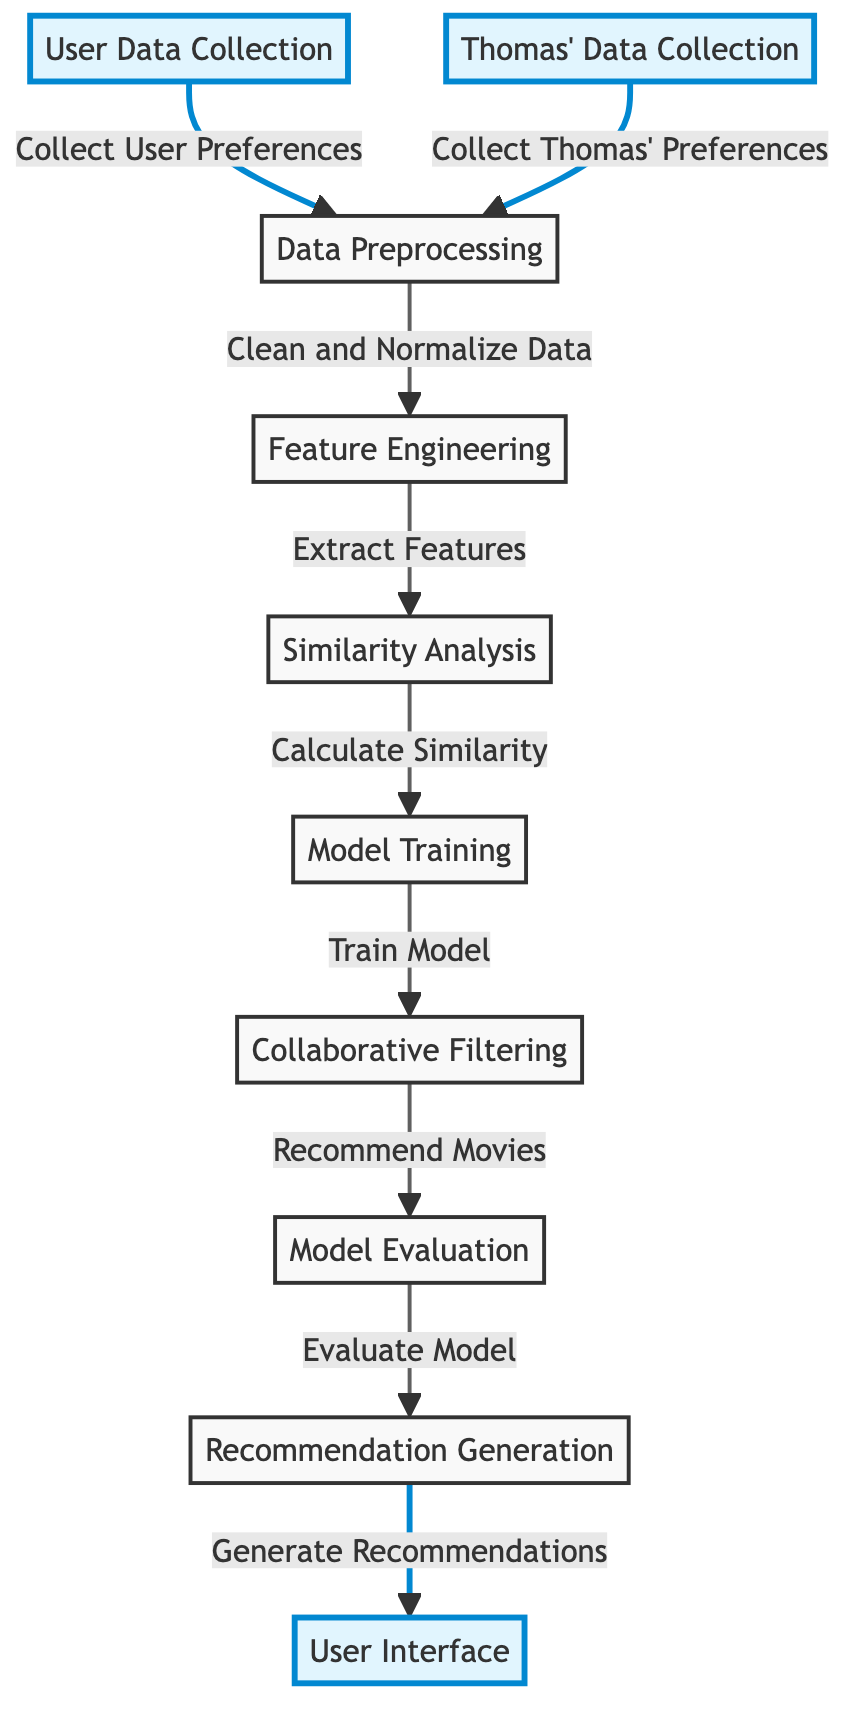What is the first step in the movie recommendation system? The diagram clearly indicates that the first step is "User Data Collection," which is represented as node A. This collection focuses on capturing user preferences.
Answer: User Data Collection How many main process steps are there in the diagram? By counting the nodes from "User Data Collection" to "User Interface," we find a total of 9 distinct steps that make up the main process of the recommendation system.
Answer: 9 What node comes after "Similarity Analysis"? Looking at the flow of the diagram, we see that "Model Training" follows "Similarity Analysis," which is represented as node F leading to node G.
Answer: Model Training Which two nodes are highlighted in the diagram? The diagram highlights the nodes "User Data Collection" and "User Interface," both marked in a distinctive color to show their significance in the process.
Answer: User Data Collection, User Interface What is the output of the entire diagram? The final node in the diagram is "User Interface," which represents the output where the recommendations are presented to the user. This node completes the flow of the recommendation system.
Answer: User Interface What is the role of "Data Preprocessing" in the diagram? The "Data Preprocessing" step, represented as node C, focuses on cleaning and normalizing the collected data, which is crucial for accurate analysis and effective recommendations.
Answer: Clean and Normalize Data What does the "Collaborative Filtering" node output? The node "Collaborative Filtering," which is node G, outputs movie recommendations based on the model's training and user similarities calculated in the previous steps.
Answer: Recommend Movies How does "Thomas' Data Collection" contribute to the overall process? "Thomas' Data Collection" plays a vital role by contributing Thomas' preferences to the collective user data, ensuring that the recommendations can be personalized based on shared interests.
Answer: Collect Thomas' Preferences What step follows "Model Evaluation"? From the flowchart, "Recommendation Generation" follows "Model Evaluation," which leads to the final user interface where suggestions are made.
Answer: Recommendation Generation 